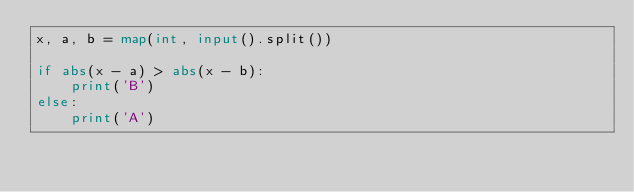Convert code to text. <code><loc_0><loc_0><loc_500><loc_500><_Python_>x, a, b = map(int, input().split())

if abs(x - a) > abs(x - b):
    print('B')
else:
    print('A')
</code> 